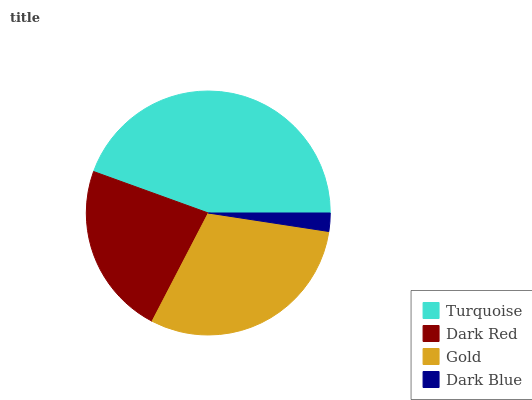Is Dark Blue the minimum?
Answer yes or no. Yes. Is Turquoise the maximum?
Answer yes or no. Yes. Is Dark Red the minimum?
Answer yes or no. No. Is Dark Red the maximum?
Answer yes or no. No. Is Turquoise greater than Dark Red?
Answer yes or no. Yes. Is Dark Red less than Turquoise?
Answer yes or no. Yes. Is Dark Red greater than Turquoise?
Answer yes or no. No. Is Turquoise less than Dark Red?
Answer yes or no. No. Is Gold the high median?
Answer yes or no. Yes. Is Dark Red the low median?
Answer yes or no. Yes. Is Turquoise the high median?
Answer yes or no. No. Is Dark Blue the low median?
Answer yes or no. No. 